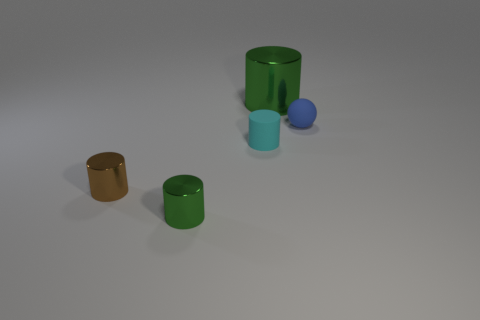Can you tell me what colors the objects in the image have? Sure, there are five objects in the image. Starting from the left, there's a small metallic gold cylinder, a larger green cylinder, a small metallic teal cylinder, a medium green cylinder, and finally a small metallic blue sphere. 